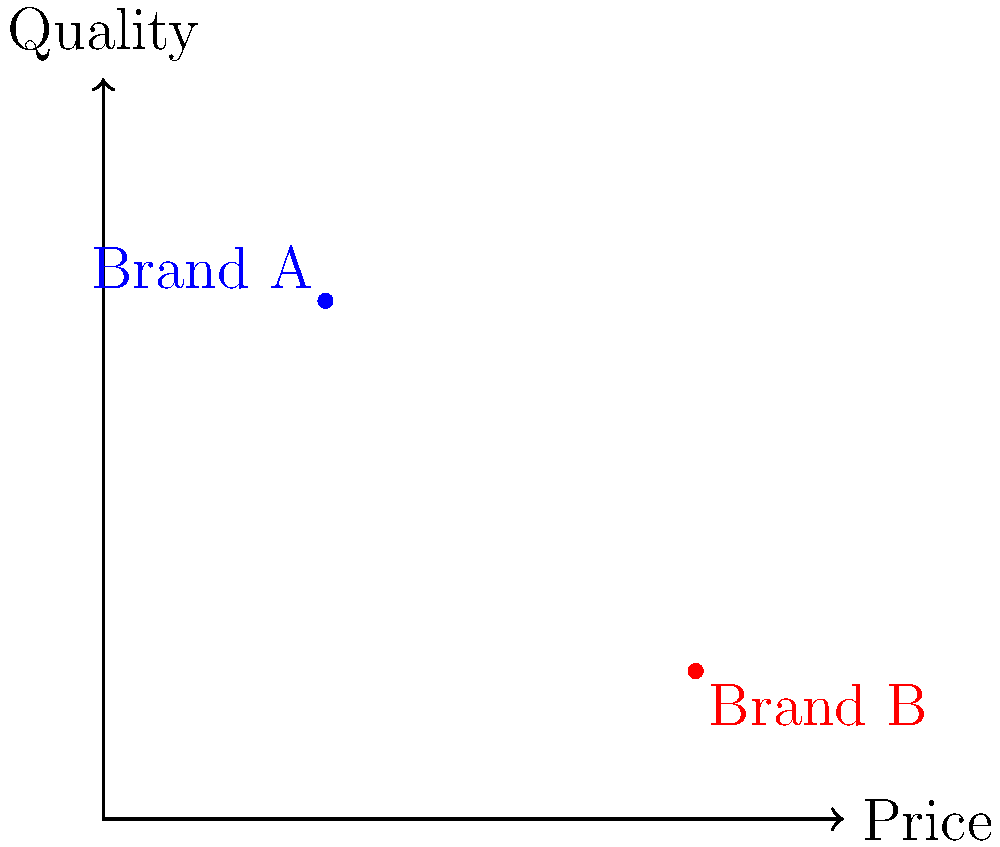As a marketing expert, you're analyzing a perceptual map of two competing brands in terms of price and quality. Brand A is positioned at (3, 7) and Brand B at (8, 2) on a 10x10 scale. What is the Euclidean distance between these two brands' positions on the perceptual map? To calculate the Euclidean distance between two points on a coordinate plane, we use the distance formula:

$$d = \sqrt{(x_2 - x_1)^2 + (y_2 - y_1)^2}$$

Where $(x_1, y_1)$ is the position of Brand A and $(x_2, y_2)$ is the position of Brand B.

Step 1: Identify the coordinates
Brand A: $(x_1, y_1) = (3, 7)$
Brand B: $(x_2, y_2) = (8, 2)$

Step 2: Plug the values into the distance formula
$$d = \sqrt{(8 - 3)^2 + (2 - 7)^2}$$

Step 3: Simplify the expressions inside the parentheses
$$d = \sqrt{5^2 + (-5)^2}$$

Step 4: Calculate the squares
$$d = \sqrt{25 + 25}$$

Step 5: Add the values under the square root
$$d = \sqrt{50}$$

Step 6: Simplify the square root
$$d = 5\sqrt{2} \approx 7.07$$

Therefore, the Euclidean distance between Brand A and Brand B on the perceptual map is $5\sqrt{2}$ or approximately 7.07 units.
Answer: $5\sqrt{2}$ units 